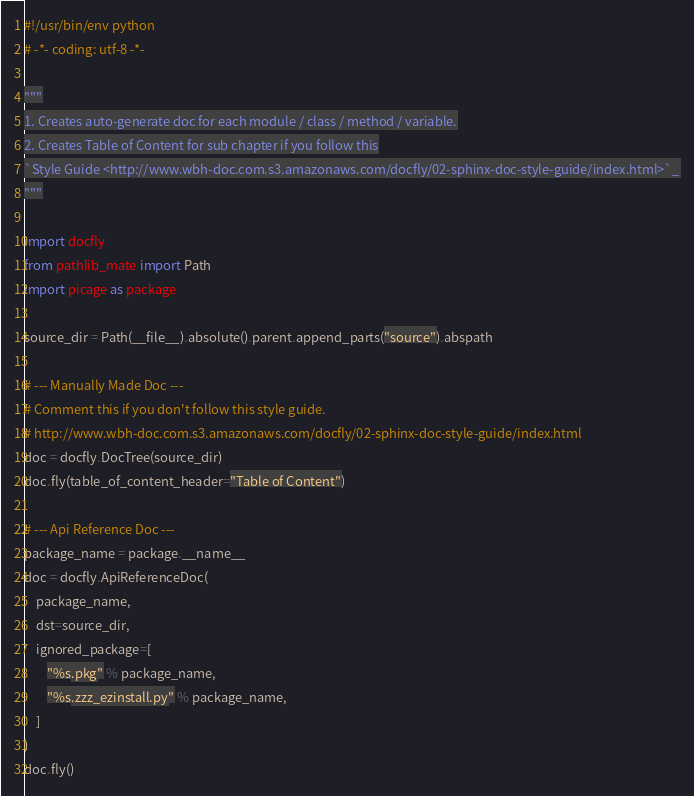<code> <loc_0><loc_0><loc_500><loc_500><_Python_>#!/usr/bin/env python
# -*- coding: utf-8 -*-

"""
1. Creates auto-generate doc for each module / class / method / variable.
2. Creates Table of Content for sub chapter if you follow this
`Style Guide <http://www.wbh-doc.com.s3.amazonaws.com/docfly/02-sphinx-doc-style-guide/index.html>`_
"""

import docfly
from pathlib_mate import Path
import picage as package

source_dir = Path(__file__).absolute().parent.append_parts("source").abspath

# --- Manually Made Doc ---
# Comment this if you don't follow this style guide.
# http://www.wbh-doc.com.s3.amazonaws.com/docfly/02-sphinx-doc-style-guide/index.html
doc = docfly.DocTree(source_dir)
doc.fly(table_of_content_header="Table of Content")

# --- Api Reference Doc ---
package_name = package.__name__
doc = docfly.ApiReferenceDoc(
    package_name,
    dst=source_dir,
    ignored_package=[
        "%s.pkg" % package_name,
        "%s.zzz_ezinstall.py" % package_name,
    ]
)
doc.fly()</code> 